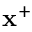Convert formula to latex. <formula><loc_0><loc_0><loc_500><loc_500>x ^ { + }</formula> 